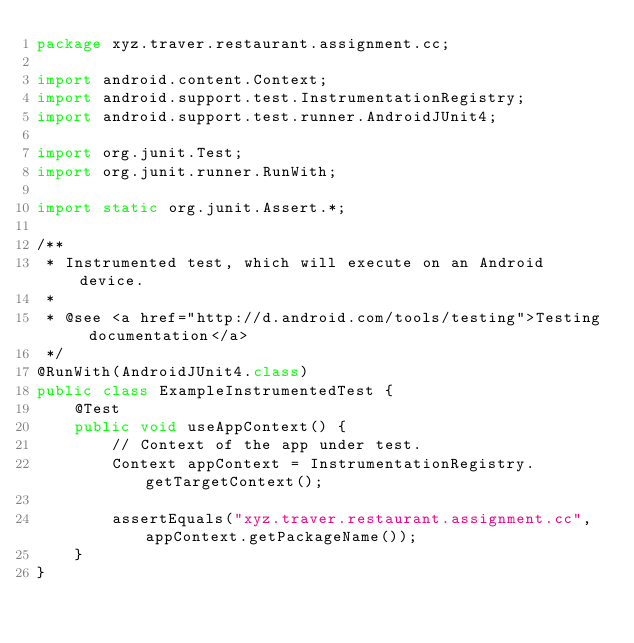Convert code to text. <code><loc_0><loc_0><loc_500><loc_500><_Java_>package xyz.traver.restaurant.assignment.cc;

import android.content.Context;
import android.support.test.InstrumentationRegistry;
import android.support.test.runner.AndroidJUnit4;

import org.junit.Test;
import org.junit.runner.RunWith;

import static org.junit.Assert.*;

/**
 * Instrumented test, which will execute on an Android device.
 *
 * @see <a href="http://d.android.com/tools/testing">Testing documentation</a>
 */
@RunWith(AndroidJUnit4.class)
public class ExampleInstrumentedTest {
    @Test
    public void useAppContext() {
        // Context of the app under test.
        Context appContext = InstrumentationRegistry.getTargetContext();

        assertEquals("xyz.traver.restaurant.assignment.cc", appContext.getPackageName());
    }
}
</code> 